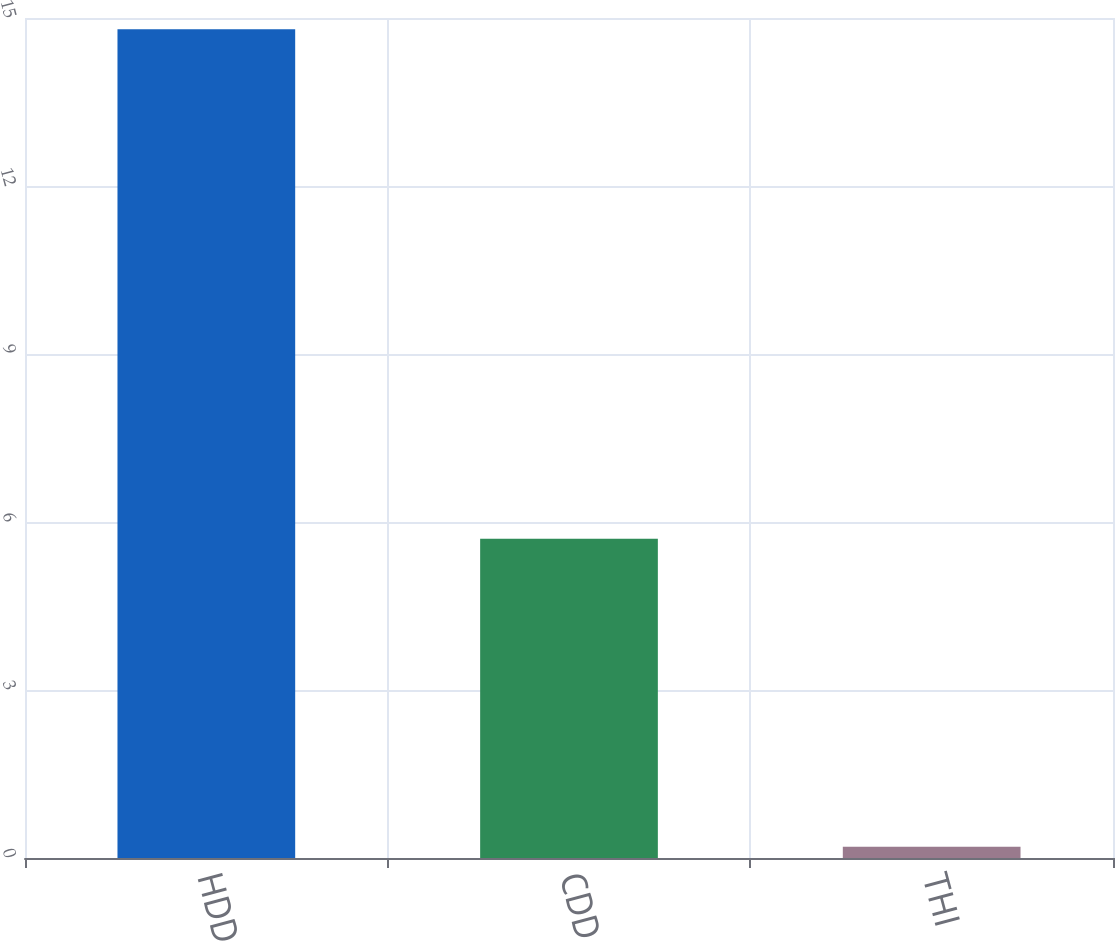Convert chart to OTSL. <chart><loc_0><loc_0><loc_500><loc_500><bar_chart><fcel>HDD<fcel>CDD<fcel>THI<nl><fcel>14.8<fcel>5.7<fcel>0.2<nl></chart> 